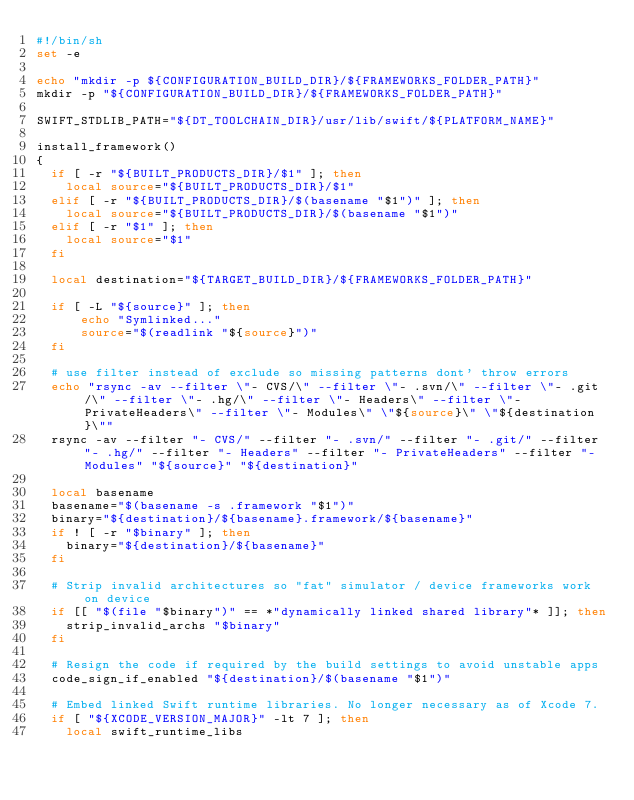Convert code to text. <code><loc_0><loc_0><loc_500><loc_500><_Bash_>#!/bin/sh
set -e

echo "mkdir -p ${CONFIGURATION_BUILD_DIR}/${FRAMEWORKS_FOLDER_PATH}"
mkdir -p "${CONFIGURATION_BUILD_DIR}/${FRAMEWORKS_FOLDER_PATH}"

SWIFT_STDLIB_PATH="${DT_TOOLCHAIN_DIR}/usr/lib/swift/${PLATFORM_NAME}"

install_framework()
{
  if [ -r "${BUILT_PRODUCTS_DIR}/$1" ]; then
    local source="${BUILT_PRODUCTS_DIR}/$1"
  elif [ -r "${BUILT_PRODUCTS_DIR}/$(basename "$1")" ]; then
    local source="${BUILT_PRODUCTS_DIR}/$(basename "$1")"
  elif [ -r "$1" ]; then
    local source="$1"
  fi

  local destination="${TARGET_BUILD_DIR}/${FRAMEWORKS_FOLDER_PATH}"

  if [ -L "${source}" ]; then
      echo "Symlinked..."
      source="$(readlink "${source}")"
  fi

  # use filter instead of exclude so missing patterns dont' throw errors
  echo "rsync -av --filter \"- CVS/\" --filter \"- .svn/\" --filter \"- .git/\" --filter \"- .hg/\" --filter \"- Headers\" --filter \"- PrivateHeaders\" --filter \"- Modules\" \"${source}\" \"${destination}\""
  rsync -av --filter "- CVS/" --filter "- .svn/" --filter "- .git/" --filter "- .hg/" --filter "- Headers" --filter "- PrivateHeaders" --filter "- Modules" "${source}" "${destination}"

  local basename
  basename="$(basename -s .framework "$1")"
  binary="${destination}/${basename}.framework/${basename}"
  if ! [ -r "$binary" ]; then
    binary="${destination}/${basename}"
  fi

  # Strip invalid architectures so "fat" simulator / device frameworks work on device
  if [[ "$(file "$binary")" == *"dynamically linked shared library"* ]]; then
    strip_invalid_archs "$binary"
  fi

  # Resign the code if required by the build settings to avoid unstable apps
  code_sign_if_enabled "${destination}/$(basename "$1")"

  # Embed linked Swift runtime libraries. No longer necessary as of Xcode 7.
  if [ "${XCODE_VERSION_MAJOR}" -lt 7 ]; then
    local swift_runtime_libs</code> 